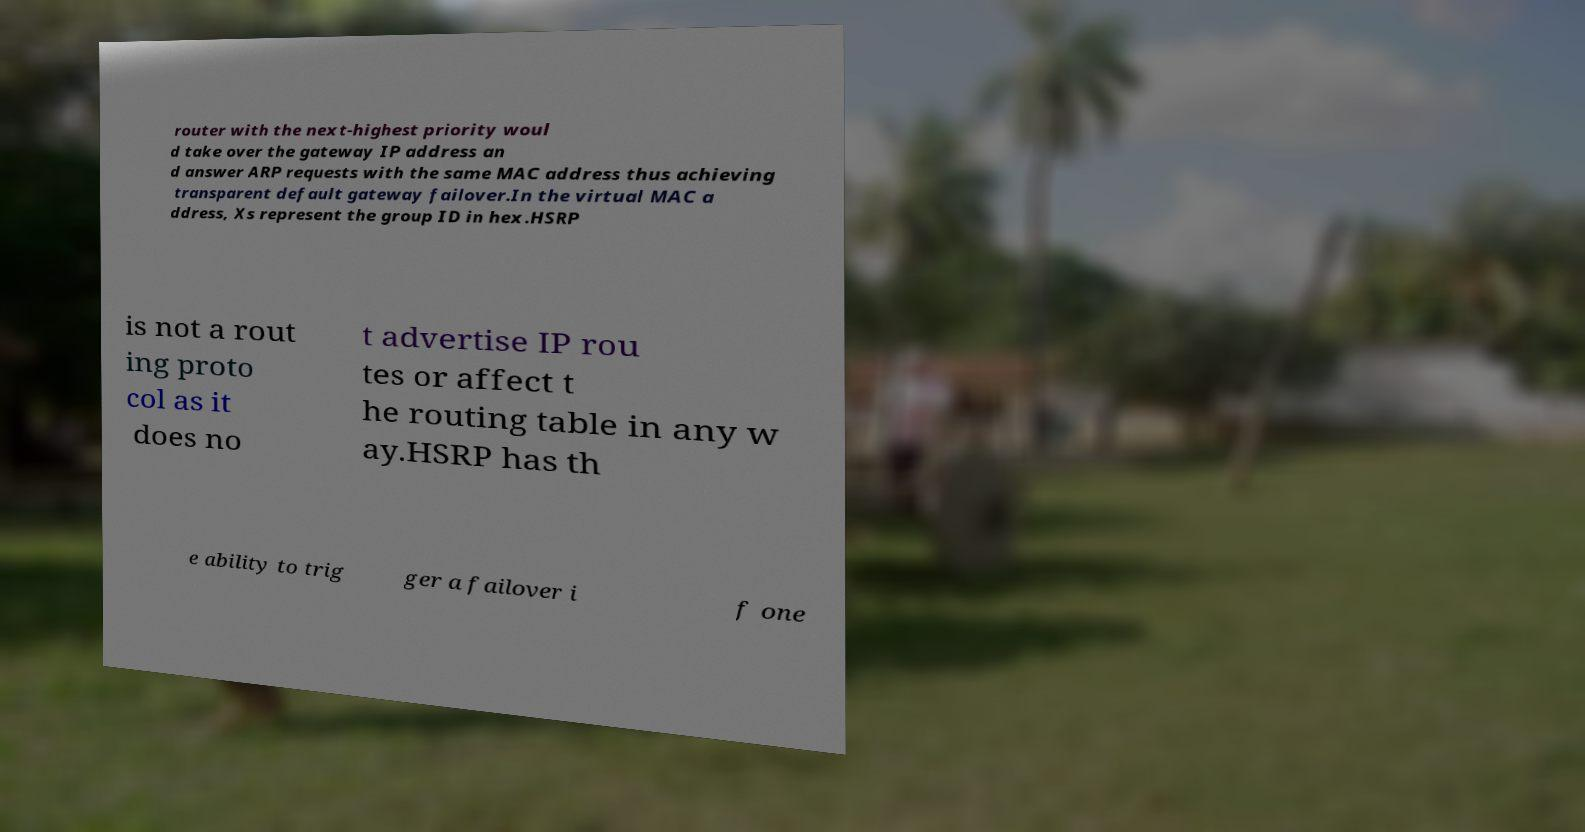Please read and relay the text visible in this image. What does it say? router with the next-highest priority woul d take over the gateway IP address an d answer ARP requests with the same MAC address thus achieving transparent default gateway failover.In the virtual MAC a ddress, Xs represent the group ID in hex.HSRP is not a rout ing proto col as it does no t advertise IP rou tes or affect t he routing table in any w ay.HSRP has th e ability to trig ger a failover i f one 